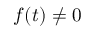Convert formula to latex. <formula><loc_0><loc_0><loc_500><loc_500>f ( t ) \neq 0</formula> 